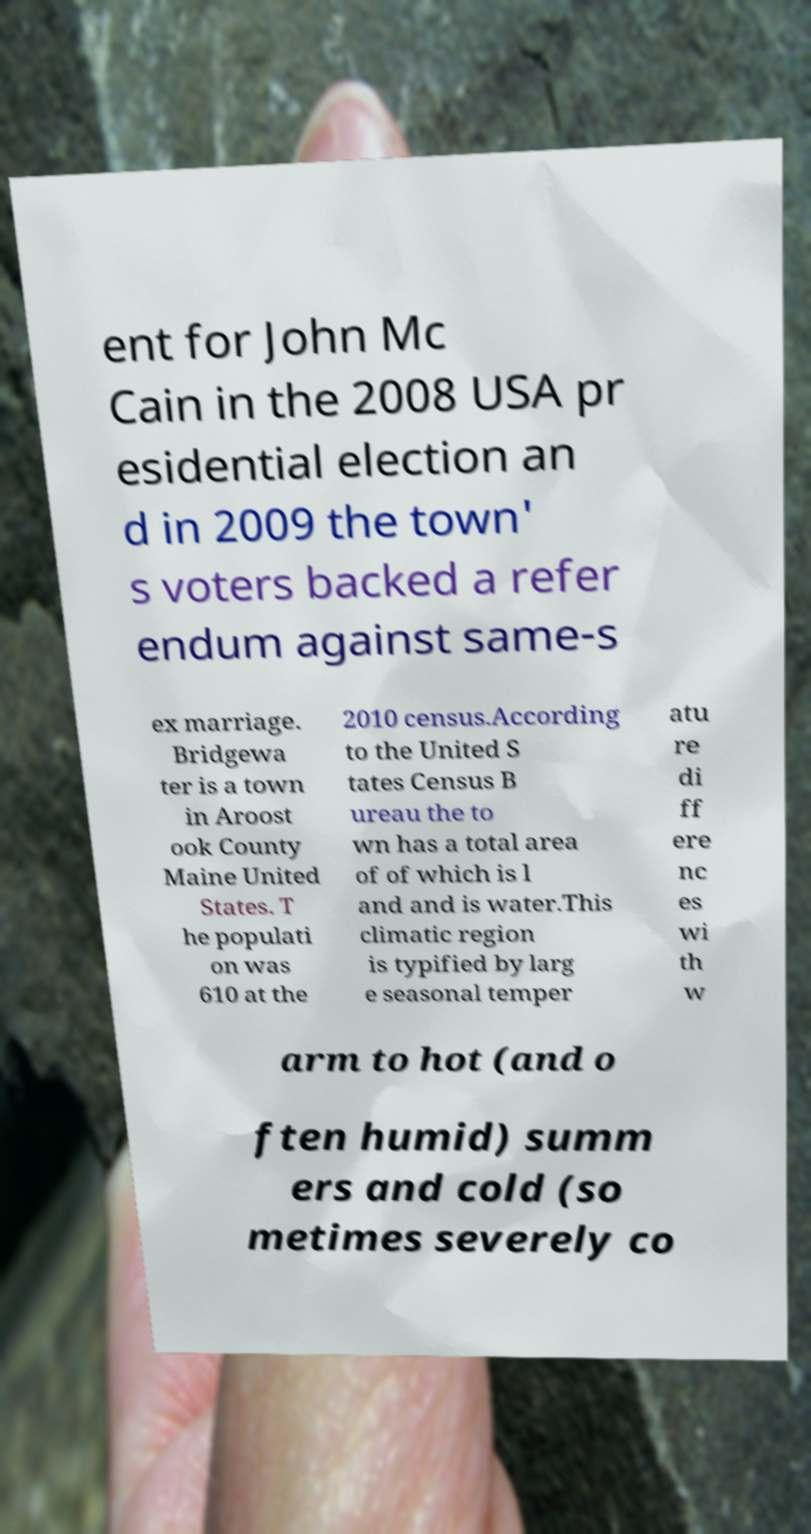For documentation purposes, I need the text within this image transcribed. Could you provide that? ent for John Mc Cain in the 2008 USA pr esidential election an d in 2009 the town' s voters backed a refer endum against same-s ex marriage. Bridgewa ter is a town in Aroost ook County Maine United States. T he populati on was 610 at the 2010 census.According to the United S tates Census B ureau the to wn has a total area of of which is l and and is water.This climatic region is typified by larg e seasonal temper atu re di ff ere nc es wi th w arm to hot (and o ften humid) summ ers and cold (so metimes severely co 